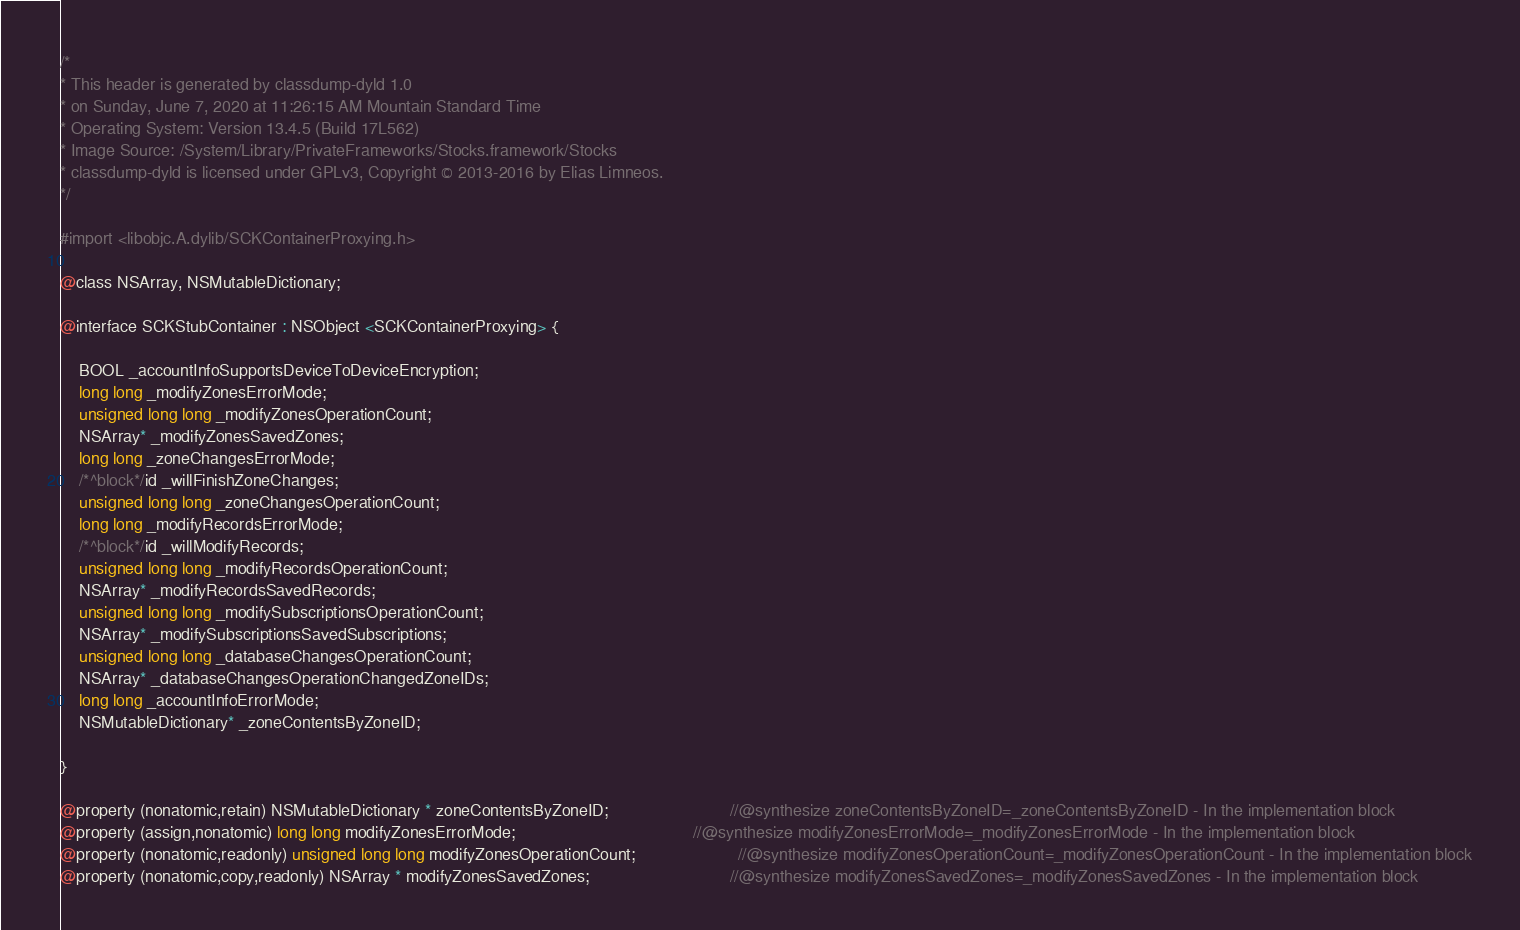Convert code to text. <code><loc_0><loc_0><loc_500><loc_500><_C_>/*
* This header is generated by classdump-dyld 1.0
* on Sunday, June 7, 2020 at 11:26:15 AM Mountain Standard Time
* Operating System: Version 13.4.5 (Build 17L562)
* Image Source: /System/Library/PrivateFrameworks/Stocks.framework/Stocks
* classdump-dyld is licensed under GPLv3, Copyright © 2013-2016 by Elias Limneos.
*/

#import <libobjc.A.dylib/SCKContainerProxying.h>

@class NSArray, NSMutableDictionary;

@interface SCKStubContainer : NSObject <SCKContainerProxying> {

	BOOL _accountInfoSupportsDeviceToDeviceEncryption;
	long long _modifyZonesErrorMode;
	unsigned long long _modifyZonesOperationCount;
	NSArray* _modifyZonesSavedZones;
	long long _zoneChangesErrorMode;
	/*^block*/id _willFinishZoneChanges;
	unsigned long long _zoneChangesOperationCount;
	long long _modifyRecordsErrorMode;
	/*^block*/id _willModifyRecords;
	unsigned long long _modifyRecordsOperationCount;
	NSArray* _modifyRecordsSavedRecords;
	unsigned long long _modifySubscriptionsOperationCount;
	NSArray* _modifySubscriptionsSavedSubscriptions;
	unsigned long long _databaseChangesOperationCount;
	NSArray* _databaseChangesOperationChangedZoneIDs;
	long long _accountInfoErrorMode;
	NSMutableDictionary* _zoneContentsByZoneID;

}

@property (nonatomic,retain) NSMutableDictionary * zoneContentsByZoneID;                          //@synthesize zoneContentsByZoneID=_zoneContentsByZoneID - In the implementation block
@property (assign,nonatomic) long long modifyZonesErrorMode;                                      //@synthesize modifyZonesErrorMode=_modifyZonesErrorMode - In the implementation block
@property (nonatomic,readonly) unsigned long long modifyZonesOperationCount;                      //@synthesize modifyZonesOperationCount=_modifyZonesOperationCount - In the implementation block
@property (nonatomic,copy,readonly) NSArray * modifyZonesSavedZones;                              //@synthesize modifyZonesSavedZones=_modifyZonesSavedZones - In the implementation block</code> 